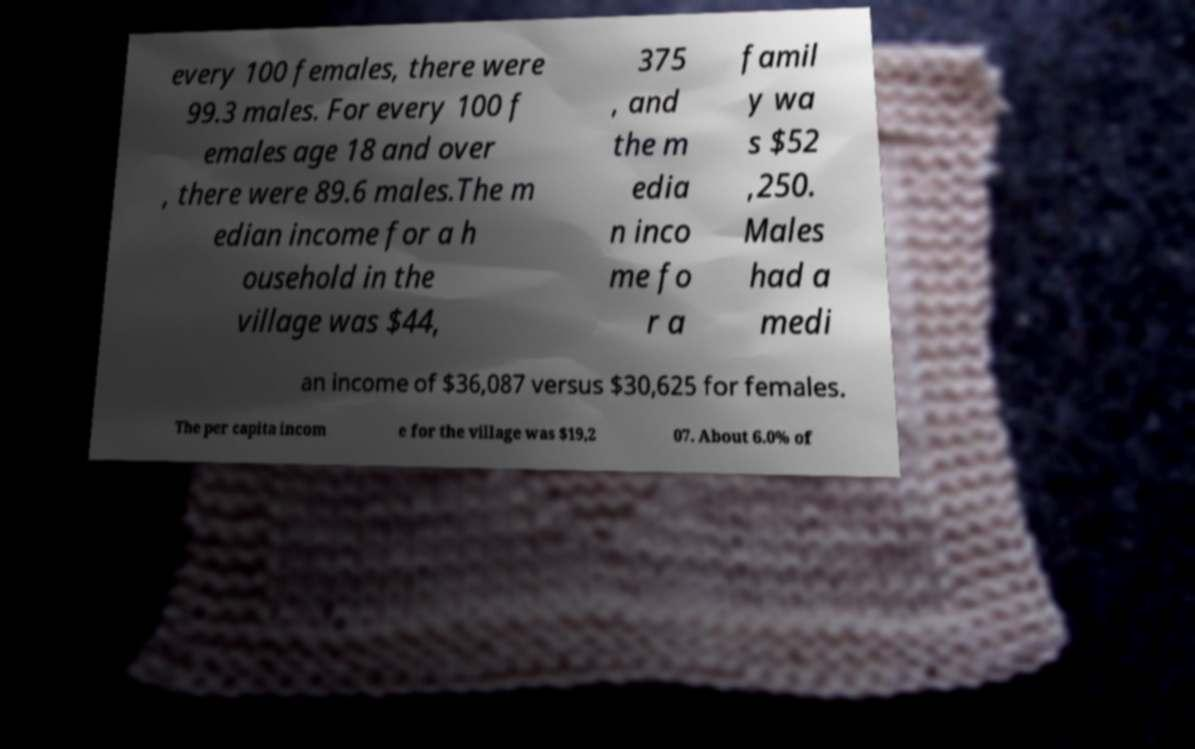For documentation purposes, I need the text within this image transcribed. Could you provide that? every 100 females, there were 99.3 males. For every 100 f emales age 18 and over , there were 89.6 males.The m edian income for a h ousehold in the village was $44, 375 , and the m edia n inco me fo r a famil y wa s $52 ,250. Males had a medi an income of $36,087 versus $30,625 for females. The per capita incom e for the village was $19,2 07. About 6.0% of 